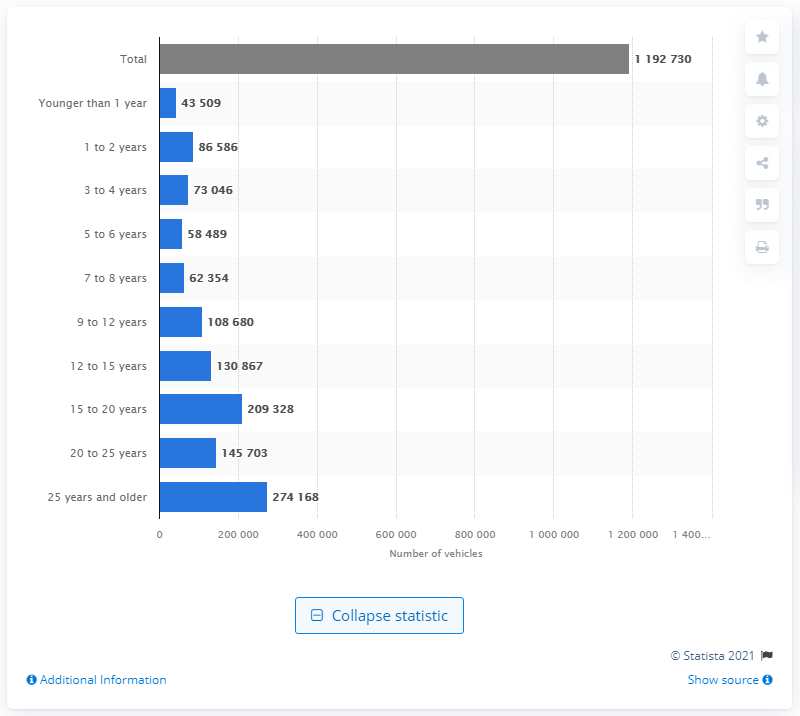Highlight a few significant elements in this photo. As of January 2020, a total of 119,2730 trailers and semi-trailers were registered in the Netherlands. The majority of trailers and semi-trailers registered in the Netherlands are 25 years or older. 